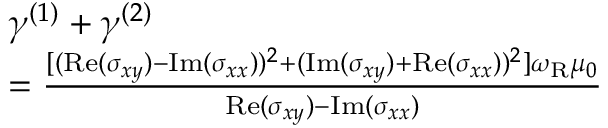Convert formula to latex. <formula><loc_0><loc_0><loc_500><loc_500>\begin{array} { r l } & { \gamma ^ { ( 1 ) } + \gamma ^ { ( 2 ) } } \\ & { = \frac { [ ( R e ( \sigma _ { x y } ) - I m ( \sigma _ { x x } ) ) ^ { 2 } + ( I m ( \sigma _ { x y } ) + R e ( \sigma _ { x x } ) ) ^ { 2 } ] \omega _ { R } \mu _ { 0 } } { R e ( \sigma _ { x y } ) - I m ( \sigma _ { x x } ) } } \end{array}</formula> 